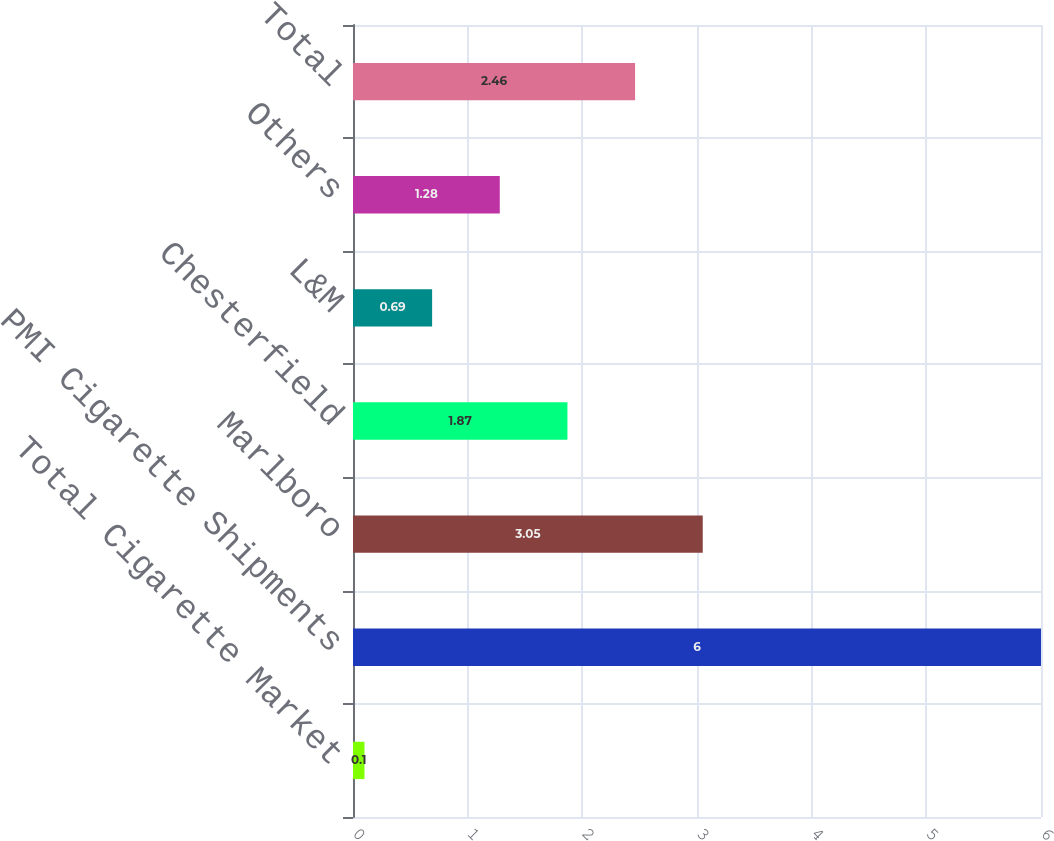Convert chart to OTSL. <chart><loc_0><loc_0><loc_500><loc_500><bar_chart><fcel>Total Cigarette Market<fcel>PMI Cigarette Shipments<fcel>Marlboro<fcel>Chesterfield<fcel>L&M<fcel>Others<fcel>Total<nl><fcel>0.1<fcel>6<fcel>3.05<fcel>1.87<fcel>0.69<fcel>1.28<fcel>2.46<nl></chart> 